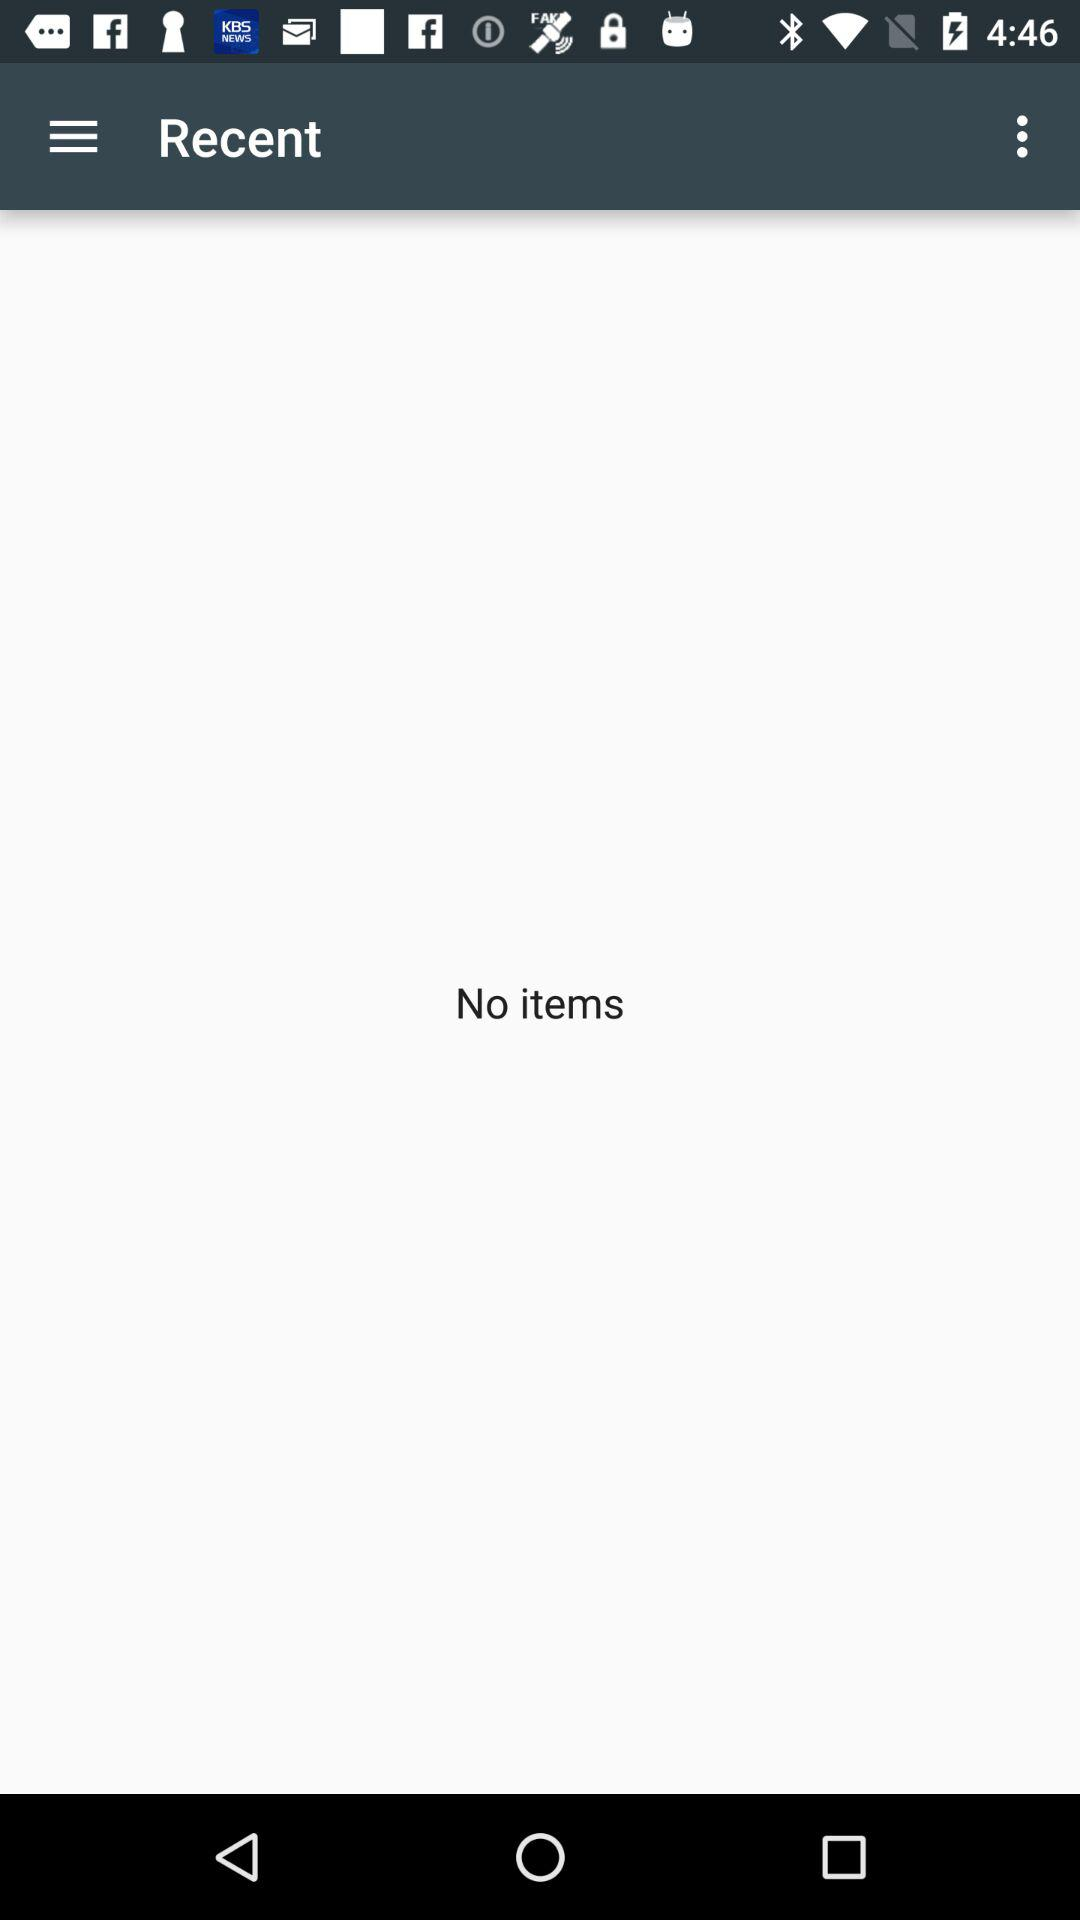Are there any items? There is no item. 